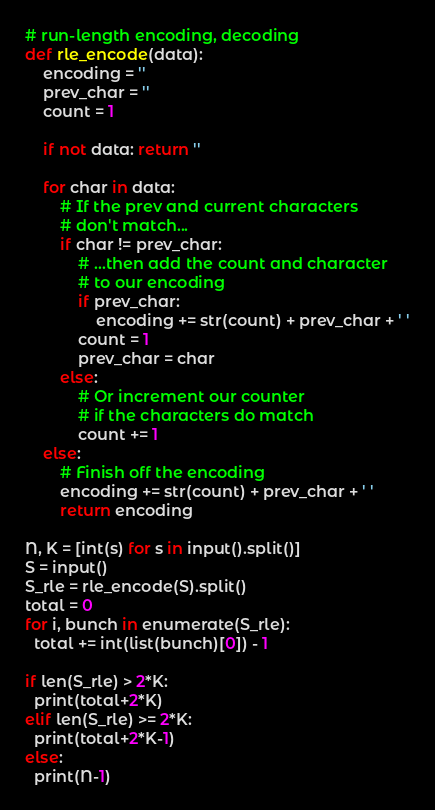<code> <loc_0><loc_0><loc_500><loc_500><_Python_># run-length encoding, decoding
def rle_encode(data):
    encoding = ''
    prev_char = ''
    count = 1

    if not data: return ''

    for char in data:
        # If the prev and current characters
        # don't match...
        if char != prev_char:
            # ...then add the count and character
            # to our encoding
            if prev_char:
                encoding += str(count) + prev_char + ' '
            count = 1
            prev_char = char
        else:
            # Or increment our counter
            # if the characters do match
            count += 1
    else:
        # Finish off the encoding
        encoding += str(count) + prev_char + ' '
        return encoding

N, K = [int(s) for s in input().split()]
S = input()
S_rle = rle_encode(S).split()
total = 0
for i, bunch in enumerate(S_rle):
  total += int(list(bunch)[0]) - 1

if len(S_rle) > 2*K:
  print(total+2*K)
elif len(S_rle) >= 2*K:
  print(total+2*K-1)
else:
  print(N-1)</code> 